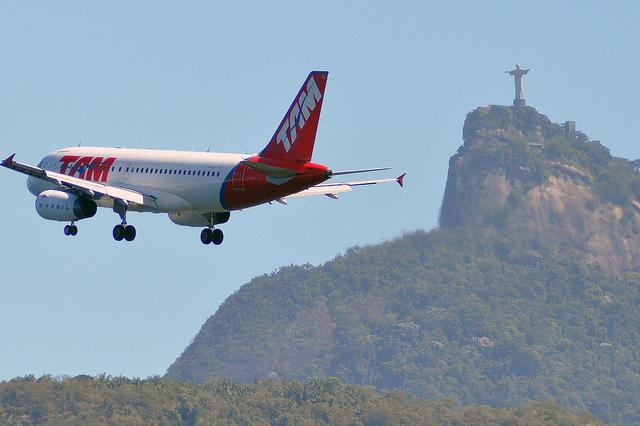Is this plane getting ready to land?
Quick response, please. No. Is the rudder of the plane larger than the statue?
Keep it brief. Yes. What religious figure is the subject of the sculpture on the top of the hill?
Quick response, please. Jesus. 